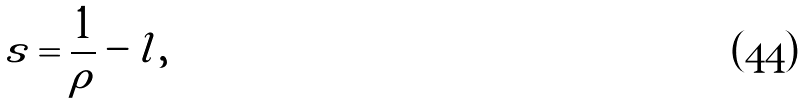<formula> <loc_0><loc_0><loc_500><loc_500>s = \frac { 1 } { \rho } - l ,</formula> 